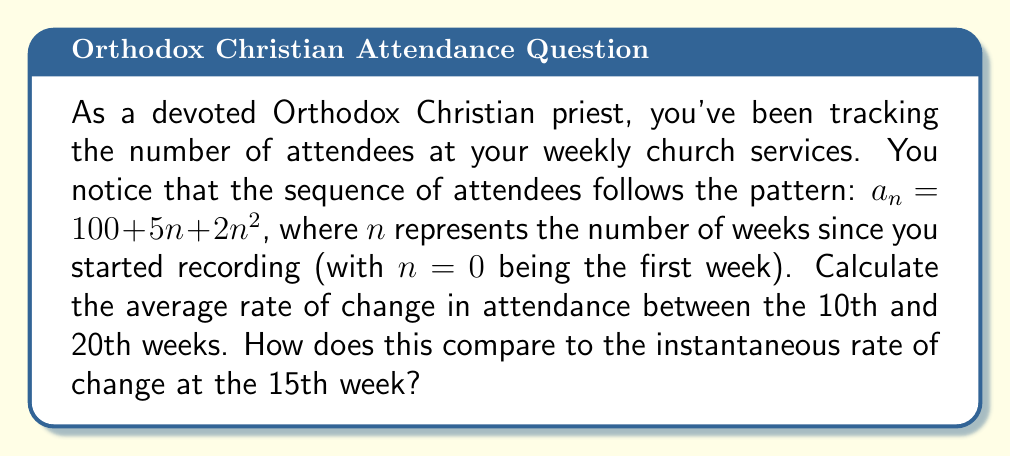Help me with this question. To solve this problem, we'll follow these steps:

1) First, let's calculate the average rate of change between the 10th and 20th weeks.

   The average rate of change is given by:
   $$\frac{a_{20} - a_{10}}{20 - 10}$$

   Let's calculate $a_{10}$ and $a_{20}$:
   
   $a_{10} = 100 + 5(10) + 2(10)^2 = 100 + 50 + 200 = 350$
   
   $a_{20} = 100 + 5(20) + 2(20)^2 = 100 + 100 + 800 = 1000$

   Now, we can calculate the average rate of change:
   $$\frac{1000 - 350}{20 - 10} = \frac{650}{10} = 65$$

2) Next, let's calculate the instantaneous rate of change at the 15th week.

   The instantaneous rate of change is given by the derivative of the function at n = 15.
   
   The derivative of $a_n = 100 + 5n + 2n^2$ is:
   $$a'_n = 5 + 4n$$

   At n = 15:
   $$a'_{15} = 5 + 4(15) = 5 + 60 = 65$$

3) Comparing the two rates:

   We see that both the average rate of change between the 10th and 20th weeks and the instantaneous rate of change at the 15th week are equal to 65 attendees per week.

This equality is not a coincidence. For quadratic functions, the average rate of change between any two points is equal to the instantaneous rate of change at the midpoint between those two points. In this case, 15 is the midpoint between 10 and 20.
Answer: The average rate of change between the 10th and 20th weeks is 65 attendees per week. The instantaneous rate of change at the 15th week is also 65 attendees per week. These rates are equal, demonstrating a property of quadratic functions where the average rate of change between two points equals the instantaneous rate of change at the midpoint. 